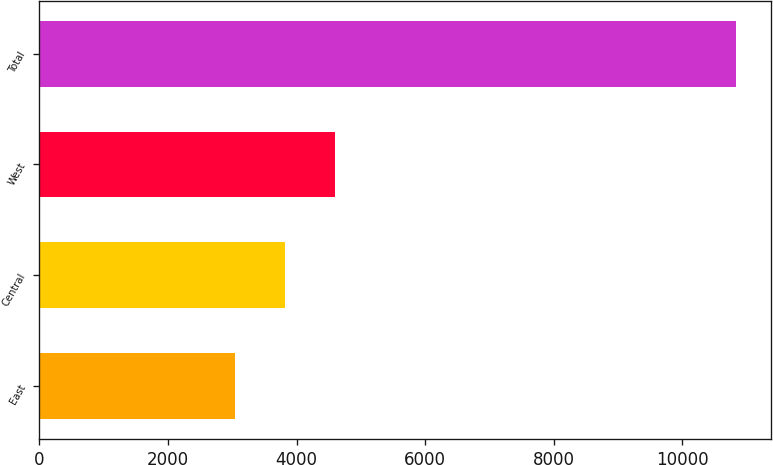<chart> <loc_0><loc_0><loc_500><loc_500><bar_chart><fcel>East<fcel>Central<fcel>West<fcel>Total<nl><fcel>3046<fcel>3824.49<fcel>4602.98<fcel>10830.9<nl></chart> 